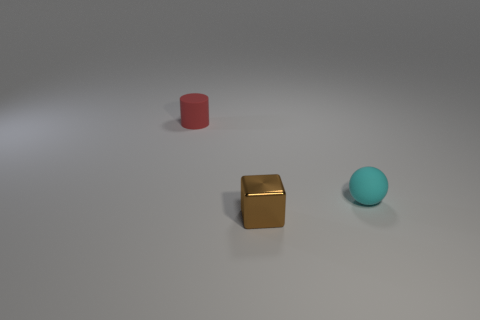How many matte cylinders are there?
Your response must be concise. 1. There is a cyan object that is the same material as the tiny red object; what is its shape?
Your answer should be compact. Sphere. Are there any other things of the same color as the cube?
Your response must be concise. No. Is the color of the ball the same as the matte thing that is left of the cyan thing?
Make the answer very short. No. Is the number of matte cylinders that are in front of the block less than the number of large gray metal cylinders?
Make the answer very short. No. What is the object that is left of the tiny block made of?
Your answer should be very brief. Rubber. What number of other things are the same size as the red matte object?
Provide a succinct answer. 2. What is the shape of the tiny matte object that is in front of the object behind the rubber thing on the right side of the tiny red matte thing?
Keep it short and to the point. Sphere. Are there fewer small red matte cylinders than objects?
Offer a very short reply. Yes. Are there any small rubber objects behind the tiny cyan ball?
Your response must be concise. Yes. 